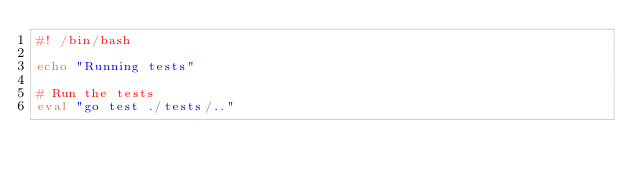Convert code to text. <code><loc_0><loc_0><loc_500><loc_500><_Bash_>#! /bin/bash

echo "Running tests"

# Run the tests
eval "go test ./tests/.."
</code> 